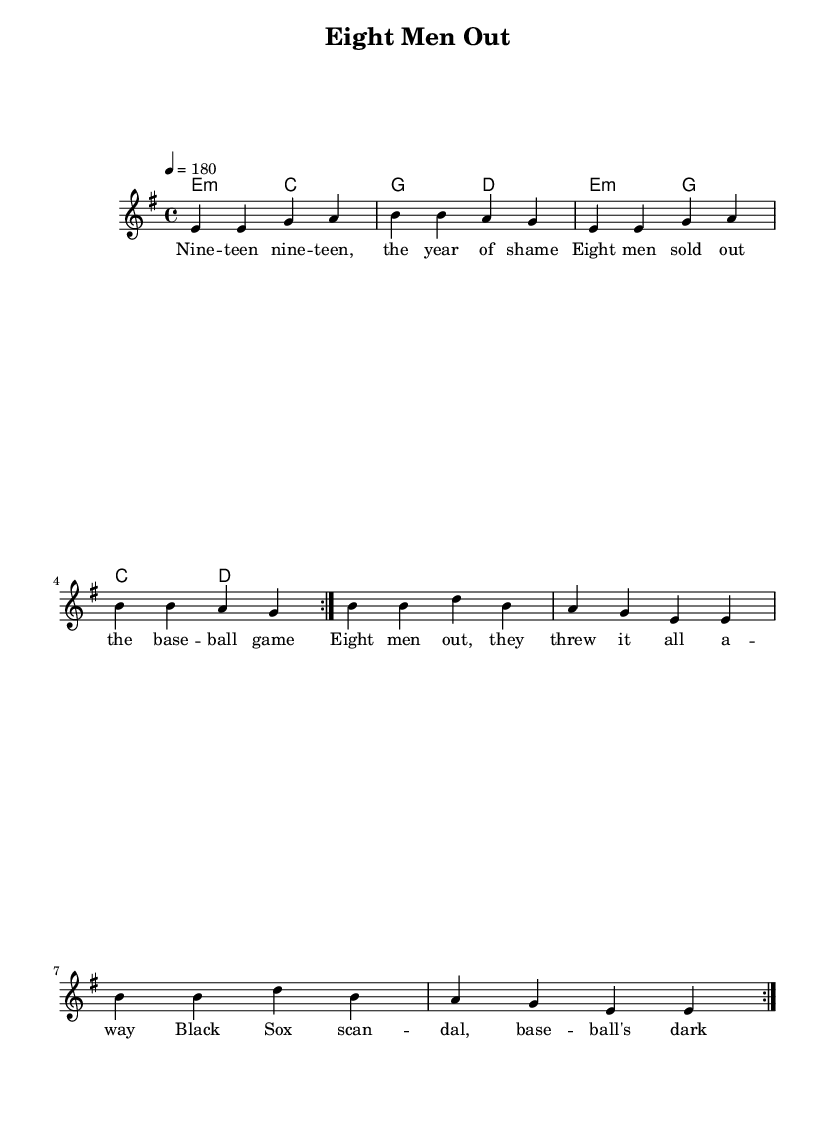What is the key signature of this music? The key signature is indicated at the beginning of the score and shows E minor, which has one sharp (F#).
Answer: E minor What is the time signature of this music? The time signature is found near the beginning of the score, indicated as 4/4, meaning there are four beats in each measure and the quarter note receives one beat.
Answer: 4/4 What is the tempo marking of this music? The tempo is specified at the beginning, stating it as "4 = 180", which means the quarter note should be played at a speed of 180 beats per minute.
Answer: 180 How many measures are repeated in this music? The presence of the "volta" directive indicates that the section within the repeat signs is to be played twice, so there are two measures repeated.
Answer: 2 What is the song title indicated in the header? The title can be found in the header section of the score where it states "Eight Men Out."
Answer: Eight Men Out What type of musical chords are primarily used in this piece? The chord structure shows that the music predominantly employs minor chords, as seen in the use of E minor and C minor in the chord layout.
Answer: Minor chords What theme is expressed in the lyrics of this song? The lyrics reflect the major historical event of the Black Sox Scandal in 1919, focusing on the betrayal by the players involved and the fallout in baseball.
Answer: Betrayal 